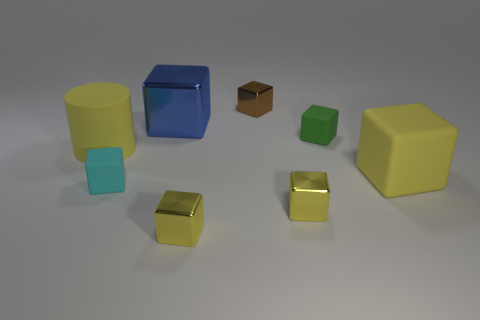There is a big rubber block; does it have the same color as the big matte object left of the green thing?
Offer a very short reply. Yes. What color is the large object that is in front of the small green matte thing and left of the green matte block?
Provide a short and direct response. Yellow. Are there any other cyan rubber objects that have the same shape as the small cyan rubber object?
Keep it short and to the point. No. Is the big cylinder the same color as the large rubber cube?
Give a very brief answer. Yes. There is a small rubber object that is in front of the cylinder; are there any tiny brown metal blocks that are right of it?
Offer a terse response. Yes. What number of objects are either big blocks that are in front of the big shiny thing or big yellow objects to the left of the large yellow rubber cube?
Give a very brief answer. 2. What number of objects are either gray cylinders or tiny things that are in front of the large blue metal block?
Give a very brief answer. 4. There is a yellow matte object to the right of the tiny shiny cube that is behind the big yellow matte thing that is on the left side of the tiny cyan matte cube; what is its size?
Keep it short and to the point. Large. What material is the cyan thing that is the same size as the green rubber block?
Give a very brief answer. Rubber. Are there any cyan blocks of the same size as the brown metallic cube?
Keep it short and to the point. Yes. 